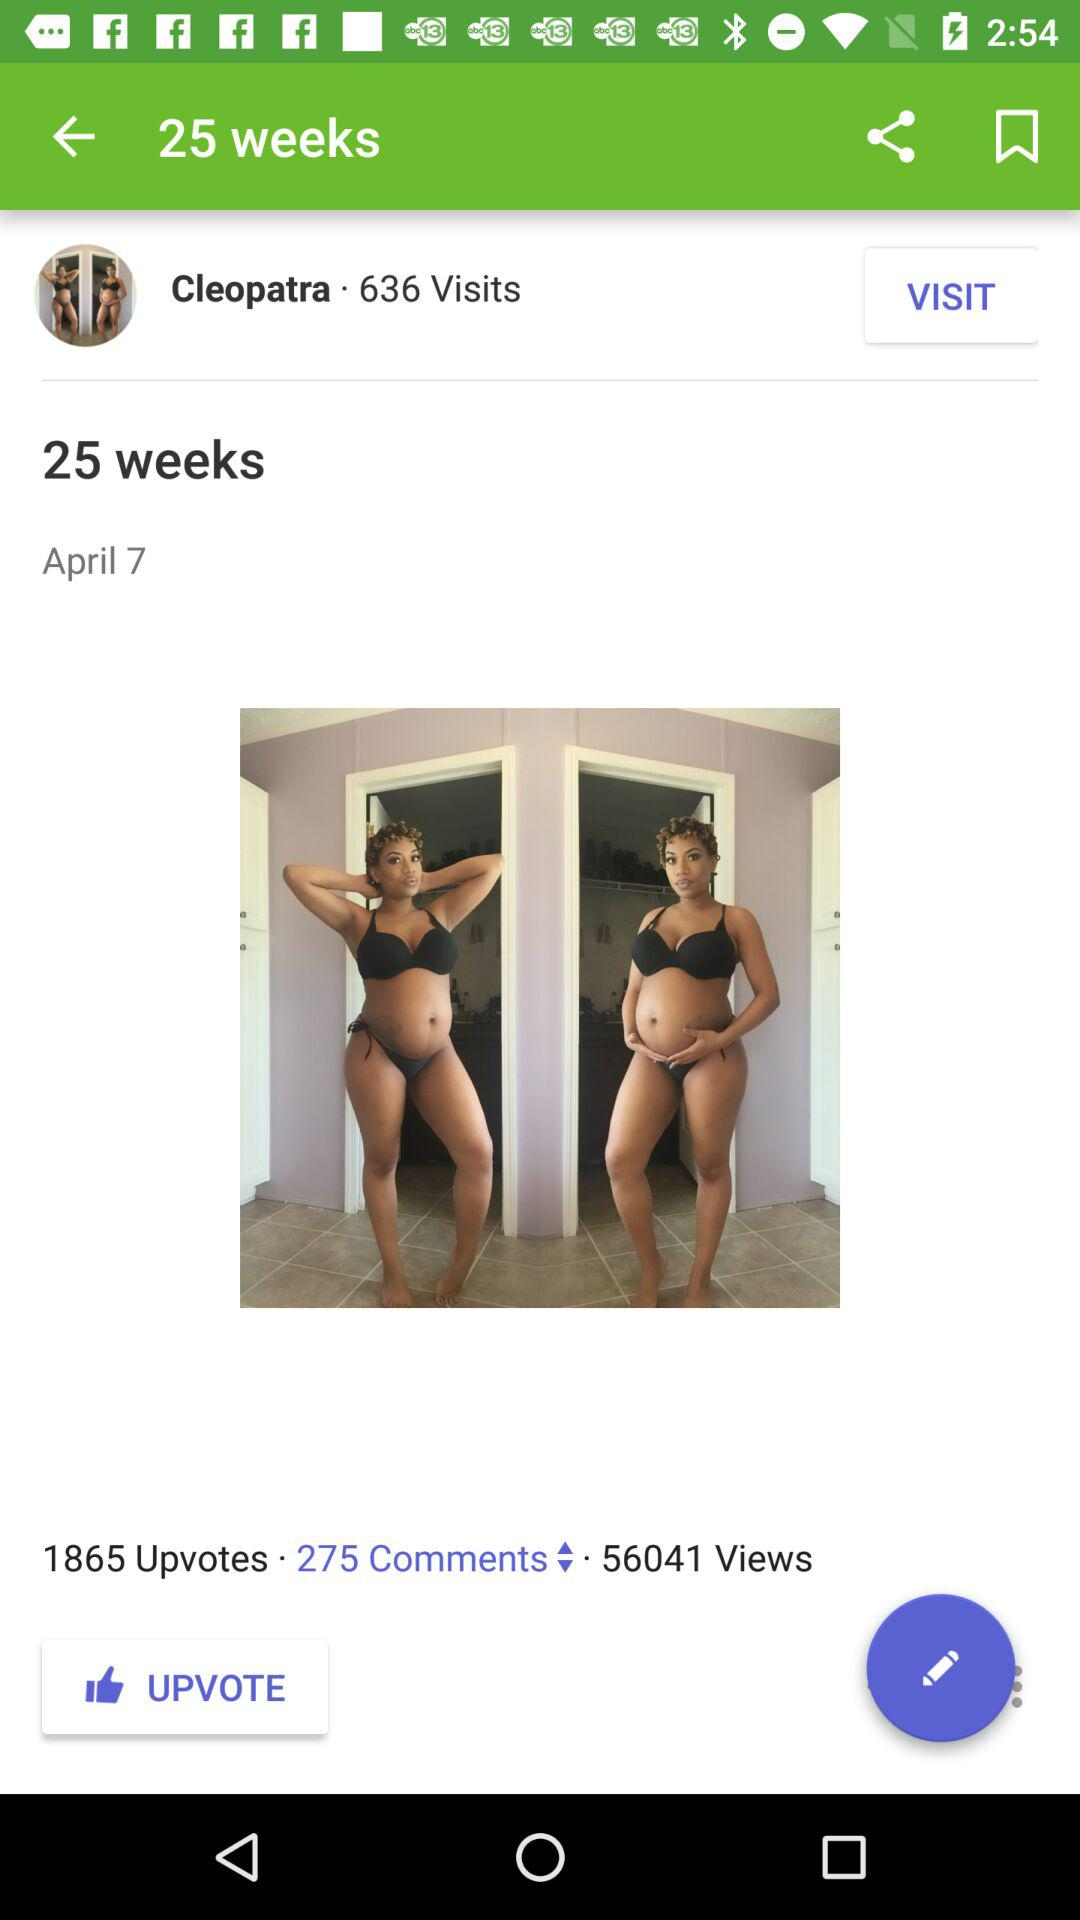How many more upvotes than comments are there on the photo?
Answer the question using a single word or phrase. 1590 